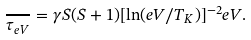Convert formula to latex. <formula><loc_0><loc_0><loc_500><loc_500>\frac { } { \tau _ { e V } } = \gamma S ( S + 1 ) [ \ln ( e V / T _ { K } ) ] ^ { - 2 } e V .</formula> 